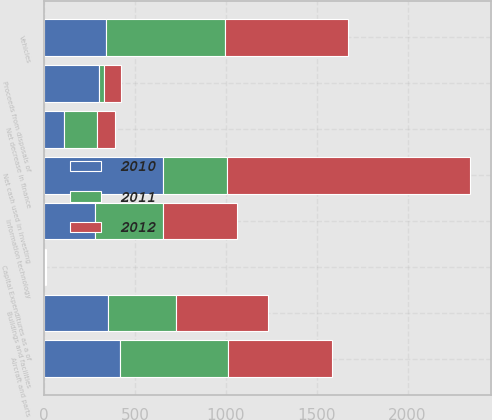<chart> <loc_0><loc_0><loc_500><loc_500><stacked_bar_chart><ecel><fcel>Net cash used in investing<fcel>Buildings and facilities<fcel>Aircraft and parts<fcel>Vehicles<fcel>Information technology<fcel>Capital Expenditures as a of<fcel>Proceeds from disposals of<fcel>Net decrease in finance<nl><fcel>2012<fcel>1335<fcel>506<fcel>568<fcel>672<fcel>407<fcel>4<fcel>95<fcel>101<nl><fcel>2011<fcel>352<fcel>373<fcel>598<fcel>659<fcel>375<fcel>3.8<fcel>27<fcel>184<nl><fcel>2010<fcel>654<fcel>352<fcel>416<fcel>339<fcel>282<fcel>2.8<fcel>304<fcel>108<nl></chart> 